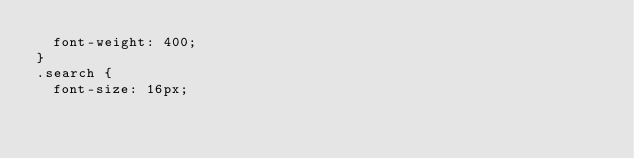<code> <loc_0><loc_0><loc_500><loc_500><_CSS_>	font-weight: 400;
}
.search {
	font-size: 16px;</code> 